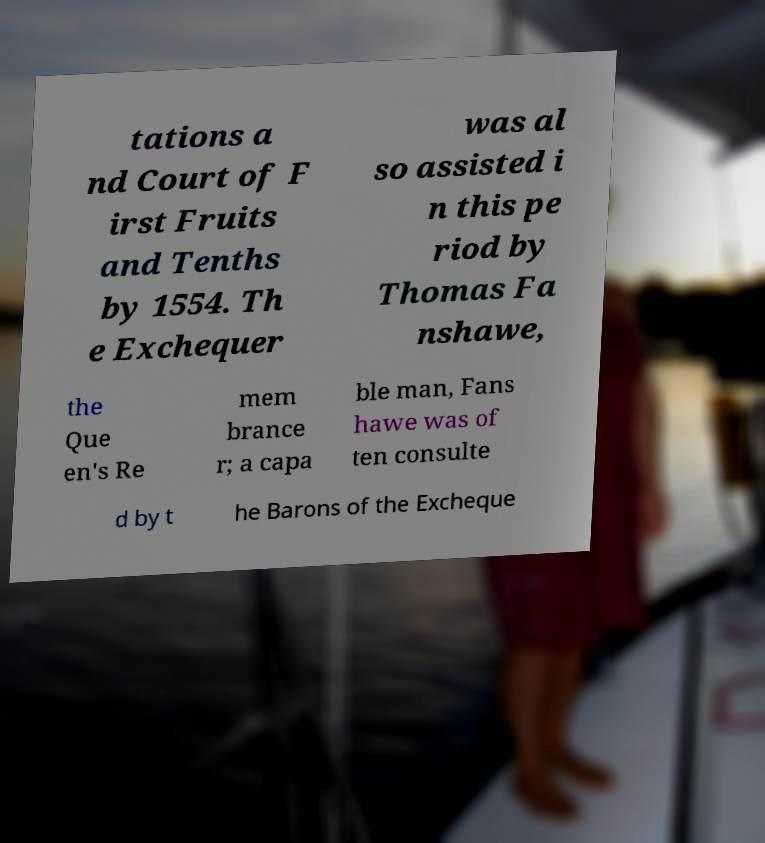There's text embedded in this image that I need extracted. Can you transcribe it verbatim? tations a nd Court of F irst Fruits and Tenths by 1554. Th e Exchequer was al so assisted i n this pe riod by Thomas Fa nshawe, the Que en's Re mem brance r; a capa ble man, Fans hawe was of ten consulte d by t he Barons of the Excheque 